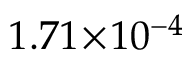<formula> <loc_0><loc_0><loc_500><loc_500>1 . 7 1 \, \times \, 1 0 ^ { - 4 }</formula> 